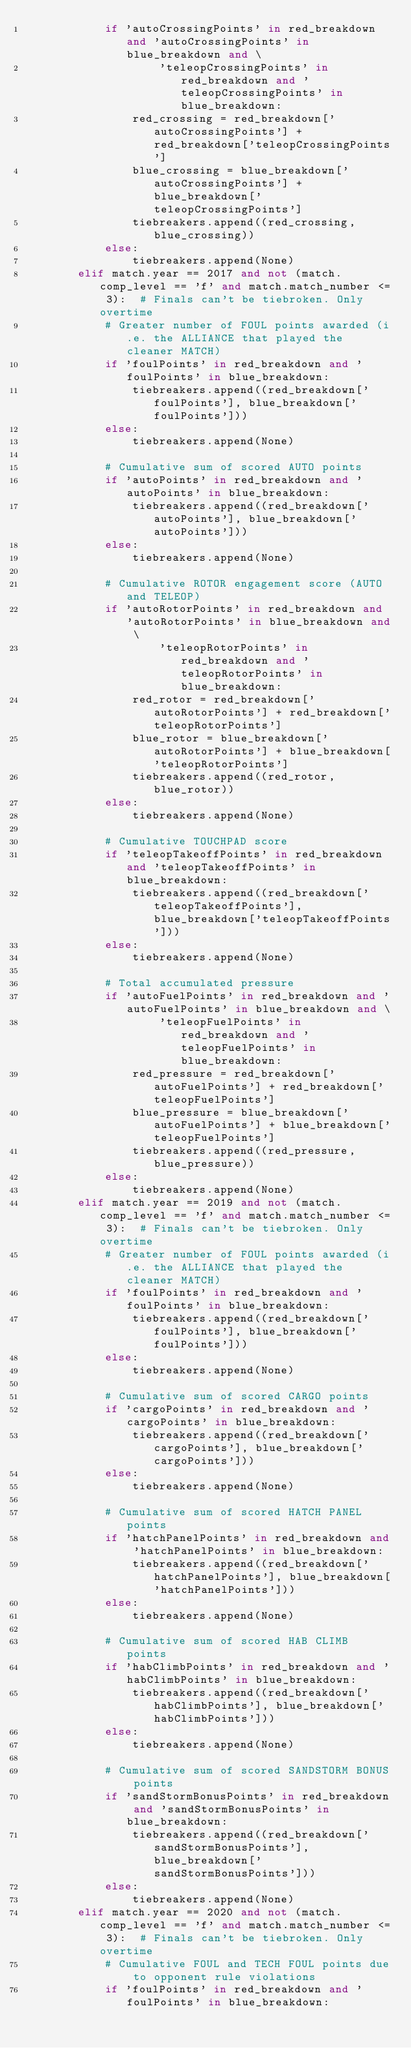Convert code to text. <code><loc_0><loc_0><loc_500><loc_500><_Python_>            if 'autoCrossingPoints' in red_breakdown and 'autoCrossingPoints' in blue_breakdown and \
                    'teleopCrossingPoints' in red_breakdown and 'teleopCrossingPoints' in blue_breakdown:
                red_crossing = red_breakdown['autoCrossingPoints'] + red_breakdown['teleopCrossingPoints']
                blue_crossing = blue_breakdown['autoCrossingPoints'] + blue_breakdown['teleopCrossingPoints']
                tiebreakers.append((red_crossing, blue_crossing))
            else:
                tiebreakers.append(None)
        elif match.year == 2017 and not (match.comp_level == 'f' and match.match_number <= 3):  # Finals can't be tiebroken. Only overtime
            # Greater number of FOUL points awarded (i.e. the ALLIANCE that played the cleaner MATCH)
            if 'foulPoints' in red_breakdown and 'foulPoints' in blue_breakdown:
                tiebreakers.append((red_breakdown['foulPoints'], blue_breakdown['foulPoints']))
            else:
                tiebreakers.append(None)

            # Cumulative sum of scored AUTO points
            if 'autoPoints' in red_breakdown and 'autoPoints' in blue_breakdown:
                tiebreakers.append((red_breakdown['autoPoints'], blue_breakdown['autoPoints']))
            else:
                tiebreakers.append(None)

            # Cumulative ROTOR engagement score (AUTO and TELEOP)
            if 'autoRotorPoints' in red_breakdown and 'autoRotorPoints' in blue_breakdown and \
                    'teleopRotorPoints' in red_breakdown and 'teleopRotorPoints' in blue_breakdown:
                red_rotor = red_breakdown['autoRotorPoints'] + red_breakdown['teleopRotorPoints']
                blue_rotor = blue_breakdown['autoRotorPoints'] + blue_breakdown['teleopRotorPoints']
                tiebreakers.append((red_rotor, blue_rotor))
            else:
                tiebreakers.append(None)

            # Cumulative TOUCHPAD score
            if 'teleopTakeoffPoints' in red_breakdown and 'teleopTakeoffPoints' in blue_breakdown:
                tiebreakers.append((red_breakdown['teleopTakeoffPoints'], blue_breakdown['teleopTakeoffPoints']))
            else:
                tiebreakers.append(None)

            # Total accumulated pressure
            if 'autoFuelPoints' in red_breakdown and 'autoFuelPoints' in blue_breakdown and \
                    'teleopFuelPoints' in red_breakdown and 'teleopFuelPoints' in blue_breakdown:
                red_pressure = red_breakdown['autoFuelPoints'] + red_breakdown['teleopFuelPoints']
                blue_pressure = blue_breakdown['autoFuelPoints'] + blue_breakdown['teleopFuelPoints']
                tiebreakers.append((red_pressure, blue_pressure))
            else:
                tiebreakers.append(None)
        elif match.year == 2019 and not (match.comp_level == 'f' and match.match_number <= 3):  # Finals can't be tiebroken. Only overtime
            # Greater number of FOUL points awarded (i.e. the ALLIANCE that played the cleaner MATCH)
            if 'foulPoints' in red_breakdown and 'foulPoints' in blue_breakdown:
                tiebreakers.append((red_breakdown['foulPoints'], blue_breakdown['foulPoints']))
            else:
                tiebreakers.append(None)

            # Cumulative sum of scored CARGO points
            if 'cargoPoints' in red_breakdown and 'cargoPoints' in blue_breakdown:
                tiebreakers.append((red_breakdown['cargoPoints'], blue_breakdown['cargoPoints']))
            else:
                tiebreakers.append(None)

            # Cumulative sum of scored HATCH PANEL points
            if 'hatchPanelPoints' in red_breakdown and 'hatchPanelPoints' in blue_breakdown:
                tiebreakers.append((red_breakdown['hatchPanelPoints'], blue_breakdown['hatchPanelPoints']))
            else:
                tiebreakers.append(None)

            # Cumulative sum of scored HAB CLIMB points
            if 'habClimbPoints' in red_breakdown and 'habClimbPoints' in blue_breakdown:
                tiebreakers.append((red_breakdown['habClimbPoints'], blue_breakdown['habClimbPoints']))
            else:
                tiebreakers.append(None)

            # Cumulative sum of scored SANDSTORM BONUS points
            if 'sandStormBonusPoints' in red_breakdown and 'sandStormBonusPoints' in blue_breakdown:
                tiebreakers.append((red_breakdown['sandStormBonusPoints'], blue_breakdown['sandStormBonusPoints']))
            else:
                tiebreakers.append(None)
        elif match.year == 2020 and not (match.comp_level == 'f' and match.match_number <= 3):  # Finals can't be tiebroken. Only overtime
            # Cumulative FOUL and TECH FOUL points due to opponent rule violations
            if 'foulPoints' in red_breakdown and 'foulPoints' in blue_breakdown:</code> 